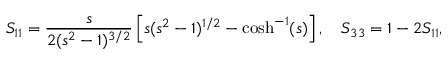<formula> <loc_0><loc_0><loc_500><loc_500>S _ { 1 1 } = \frac { s } { 2 ( s ^ { 2 } - 1 ) ^ { 3 / 2 } } \left [ s ( s ^ { 2 } - 1 ) ^ { 1 / 2 } - \cosh ^ { - 1 } ( s ) \right ] , \quad S _ { 3 3 } = 1 - 2 S _ { 1 1 } ,</formula> 